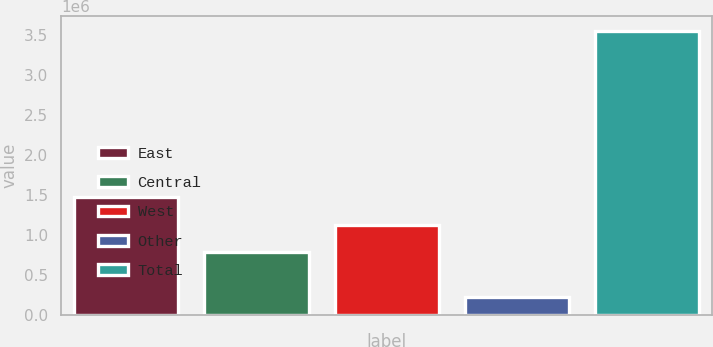<chart> <loc_0><loc_0><loc_500><loc_500><bar_chart><fcel>East<fcel>Central<fcel>West<fcel>Other<fcel>Total<nl><fcel>1.46883e+06<fcel>785469<fcel>1.11877e+06<fcel>217307<fcel>3.55037e+06<nl></chart> 